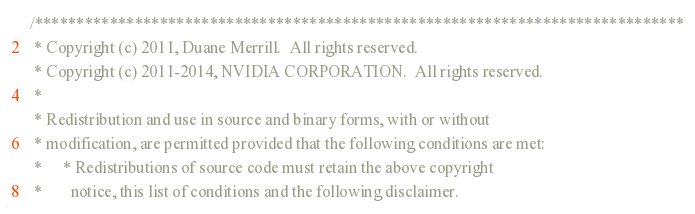Convert code to text. <code><loc_0><loc_0><loc_500><loc_500><_Cuda_>
/******************************************************************************
 * Copyright (c) 2011, Duane Merrill.  All rights reserved.
 * Copyright (c) 2011-2014, NVIDIA CORPORATION.  All rights reserved.
 *
 * Redistribution and use in source and binary forms, with or without
 * modification, are permitted provided that the following conditions are met:
 *     * Redistributions of source code must retain the above copyright
 *       notice, this list of conditions and the following disclaimer.</code> 